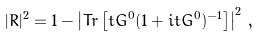<formula> <loc_0><loc_0><loc_500><loc_500>| R | ^ { 2 } = 1 - \left | T r \left [ t G ^ { 0 } ( 1 + i t G ^ { 0 } ) ^ { - 1 } \right ] \right | ^ { 2 } \, ,</formula> 